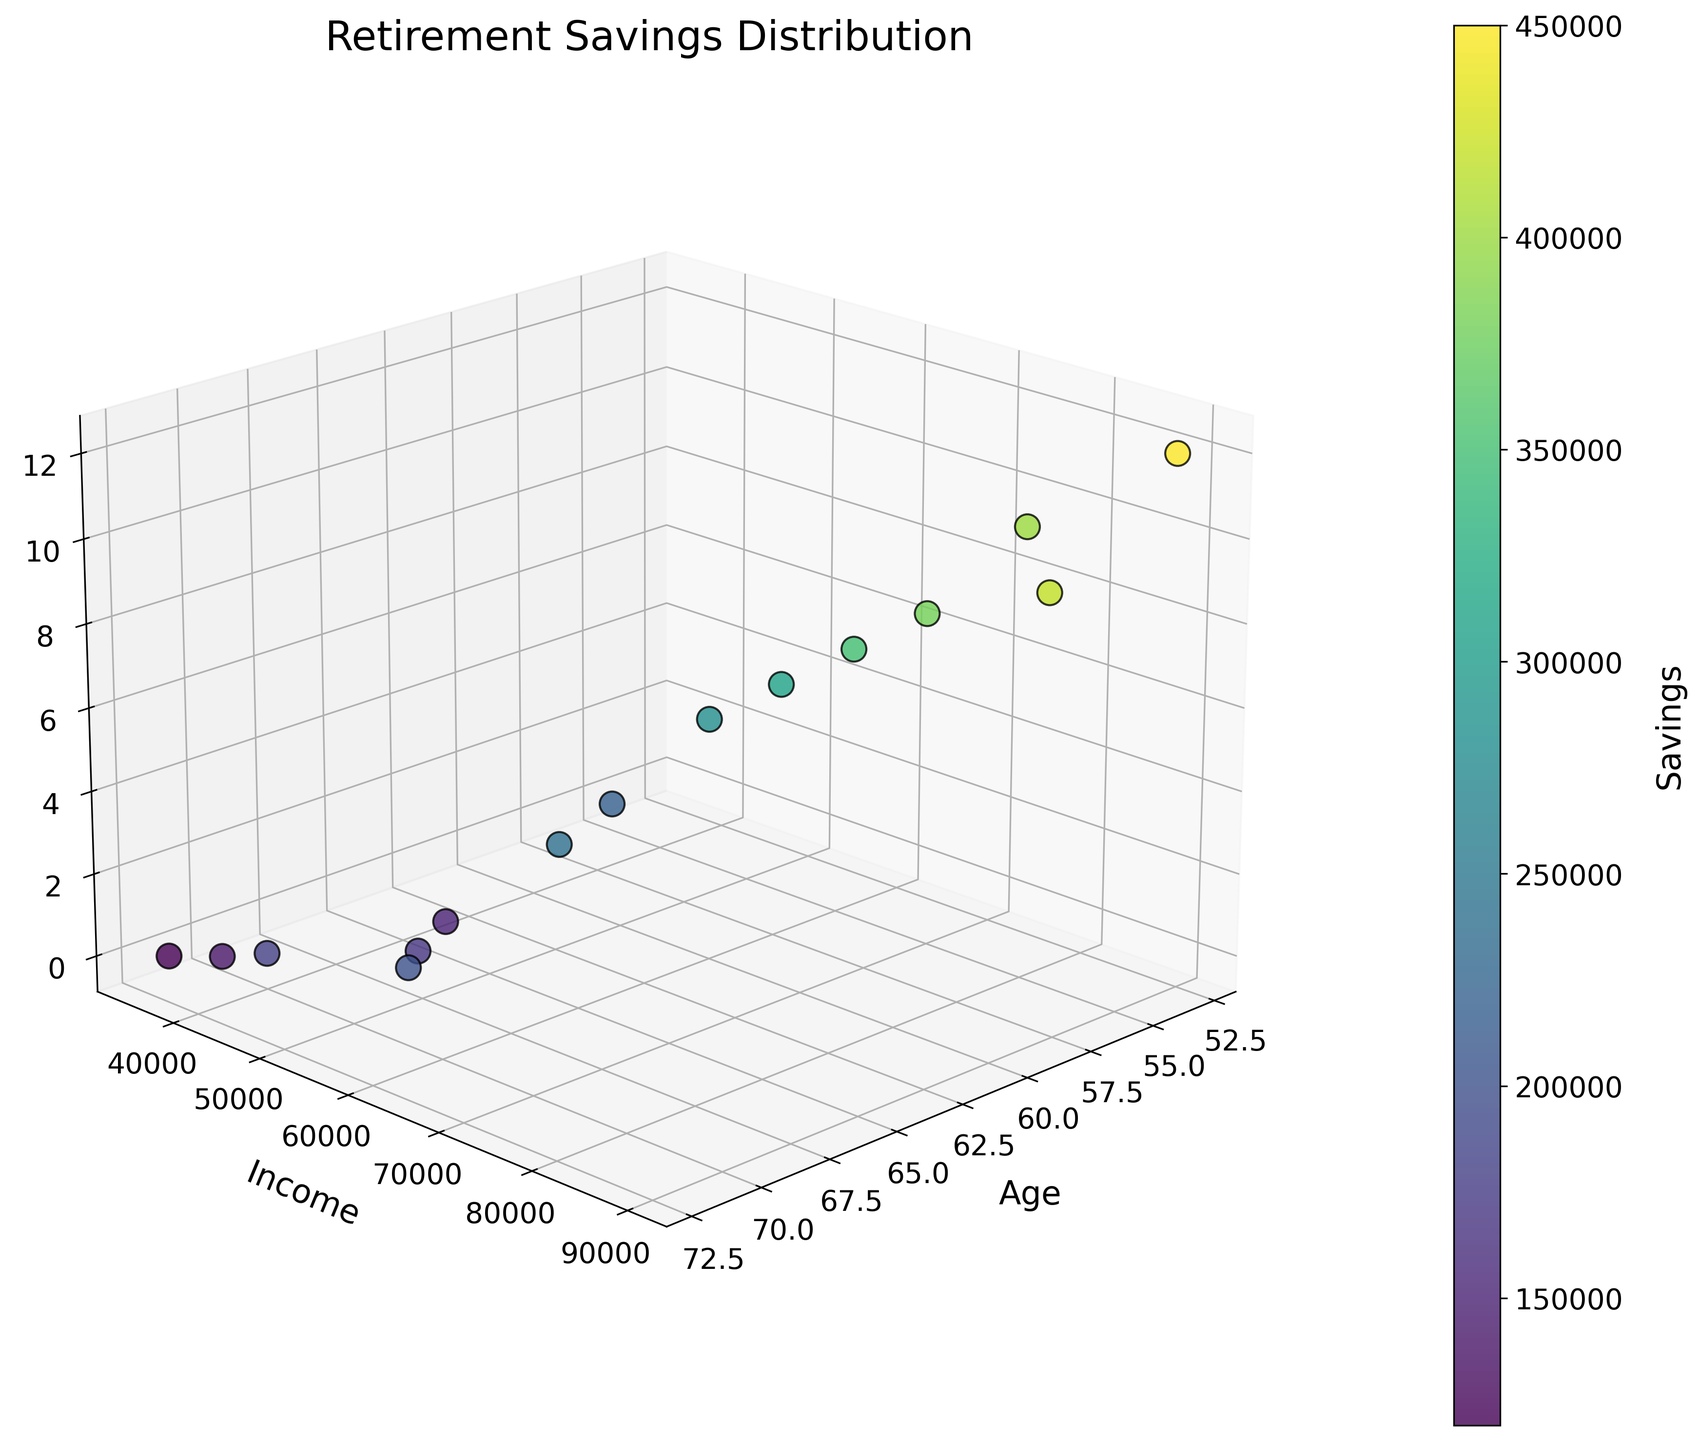What is the title of the figure? The title of the figure is displayed at the top of the plot and states the main subject of the plot, which helps us understand what the data is about.
Answer: Retirement Savings Distribution What are the labels of the three axes? The labels of the axes are located adjacent to each axis line. The X-axis is labeled 'Age', the Y-axis is labeled 'Income', and the Z-axis is labeled 'Years Until Retirement'.
Answer: Age, Income, Years Until Retirement How many data points are there in total? Each data point on the figure is represented by a dot in the 3D scatter plot. Counting each dot will give us the total number of data points.
Answer: 15 Which data point has the highest income? By looking at the Y-axis (Income) and finding the dot that is furthest along this axis, we can identify which data point has the highest income. This corresponds to the dot's location on the plot.
Answer: A data point with Age 53, Income 90000, Years Until Retirement 12, Savings 450000 What is the average savings for data points with 0 years until retirement? Identify the dots along the Z-axis that represent 0 years, note their corresponding savings values, sum these values, and then divide by the number of such data points to find the average. The savings values for 0 years until retirement are 150000, 180000, 200000, 170000, and 140000. Sum these up (150000 + 180000 + 200000 + 170000 + 140000) = 840000, and then divide by 5.
Answer: 168000 Is there a clear trend between age and savings? Examine the 3D scatter plot to identify if there's a visible pattern or relationship between the age values (X-axis) and the color intensity of the dots (Savings). If the colors (representing savings) change consistently with the increase in age, that indicates a trend. Generally, the color does not show a clear trend aligned with the age axis, indicating no strong visible correlation.
Answer: No clear trend 